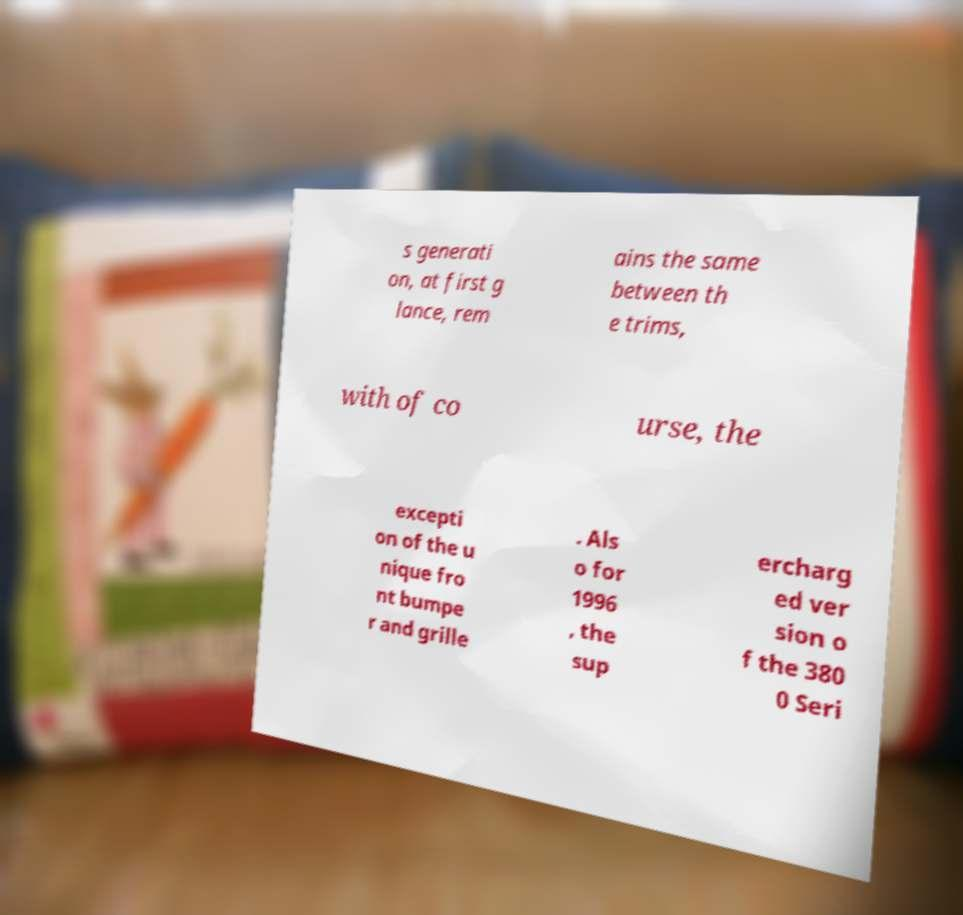Can you read and provide the text displayed in the image?This photo seems to have some interesting text. Can you extract and type it out for me? s generati on, at first g lance, rem ains the same between th e trims, with of co urse, the excepti on of the u nique fro nt bumpe r and grille . Als o for 1996 , the sup ercharg ed ver sion o f the 380 0 Seri 